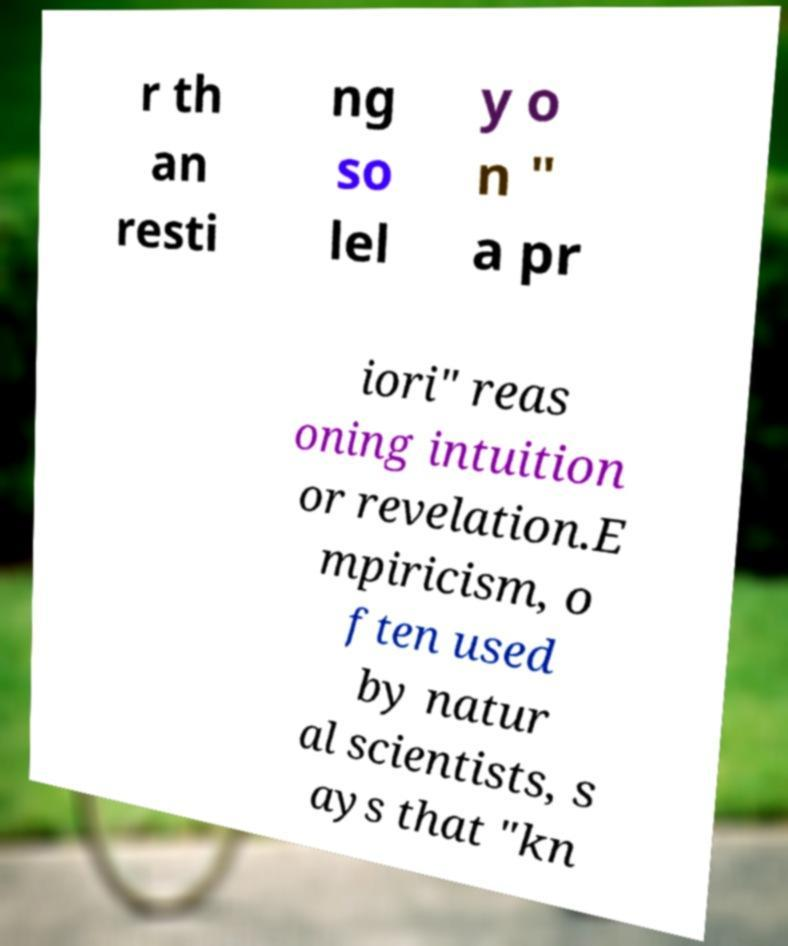I need the written content from this picture converted into text. Can you do that? r th an resti ng so lel y o n " a pr iori" reas oning intuition or revelation.E mpiricism, o ften used by natur al scientists, s ays that "kn 